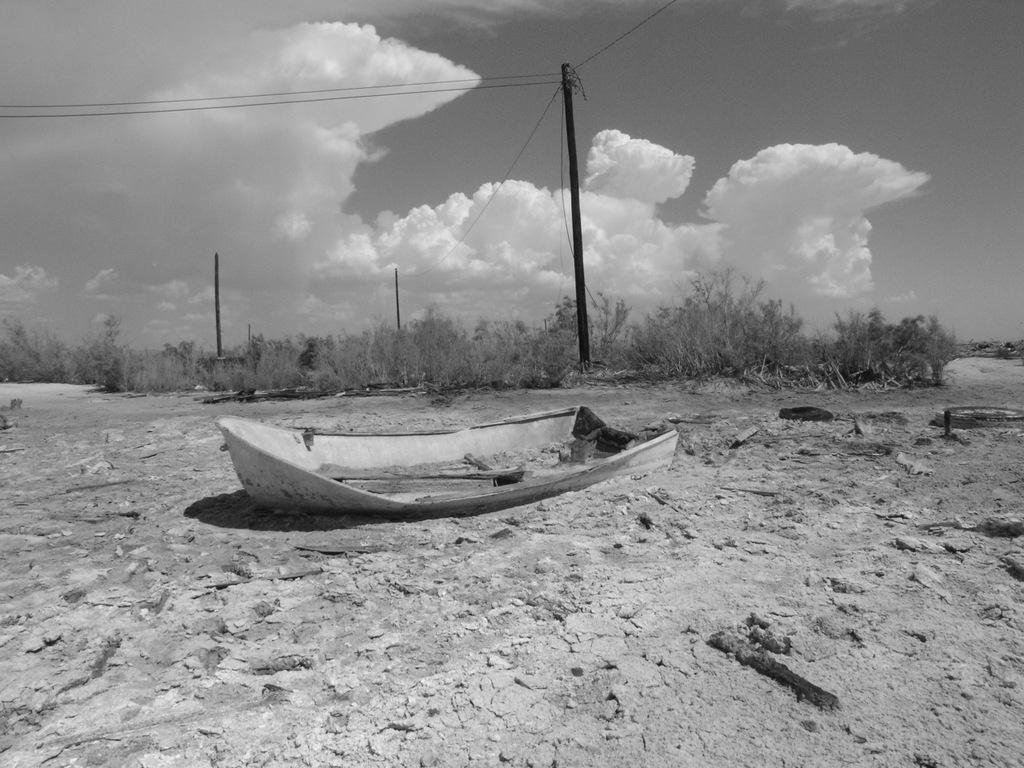Describe this image in one or two sentences. In this image I can see a boat, bushes, few poles, few wires, clouds, the sky and I can see this image is black and white in colour. 